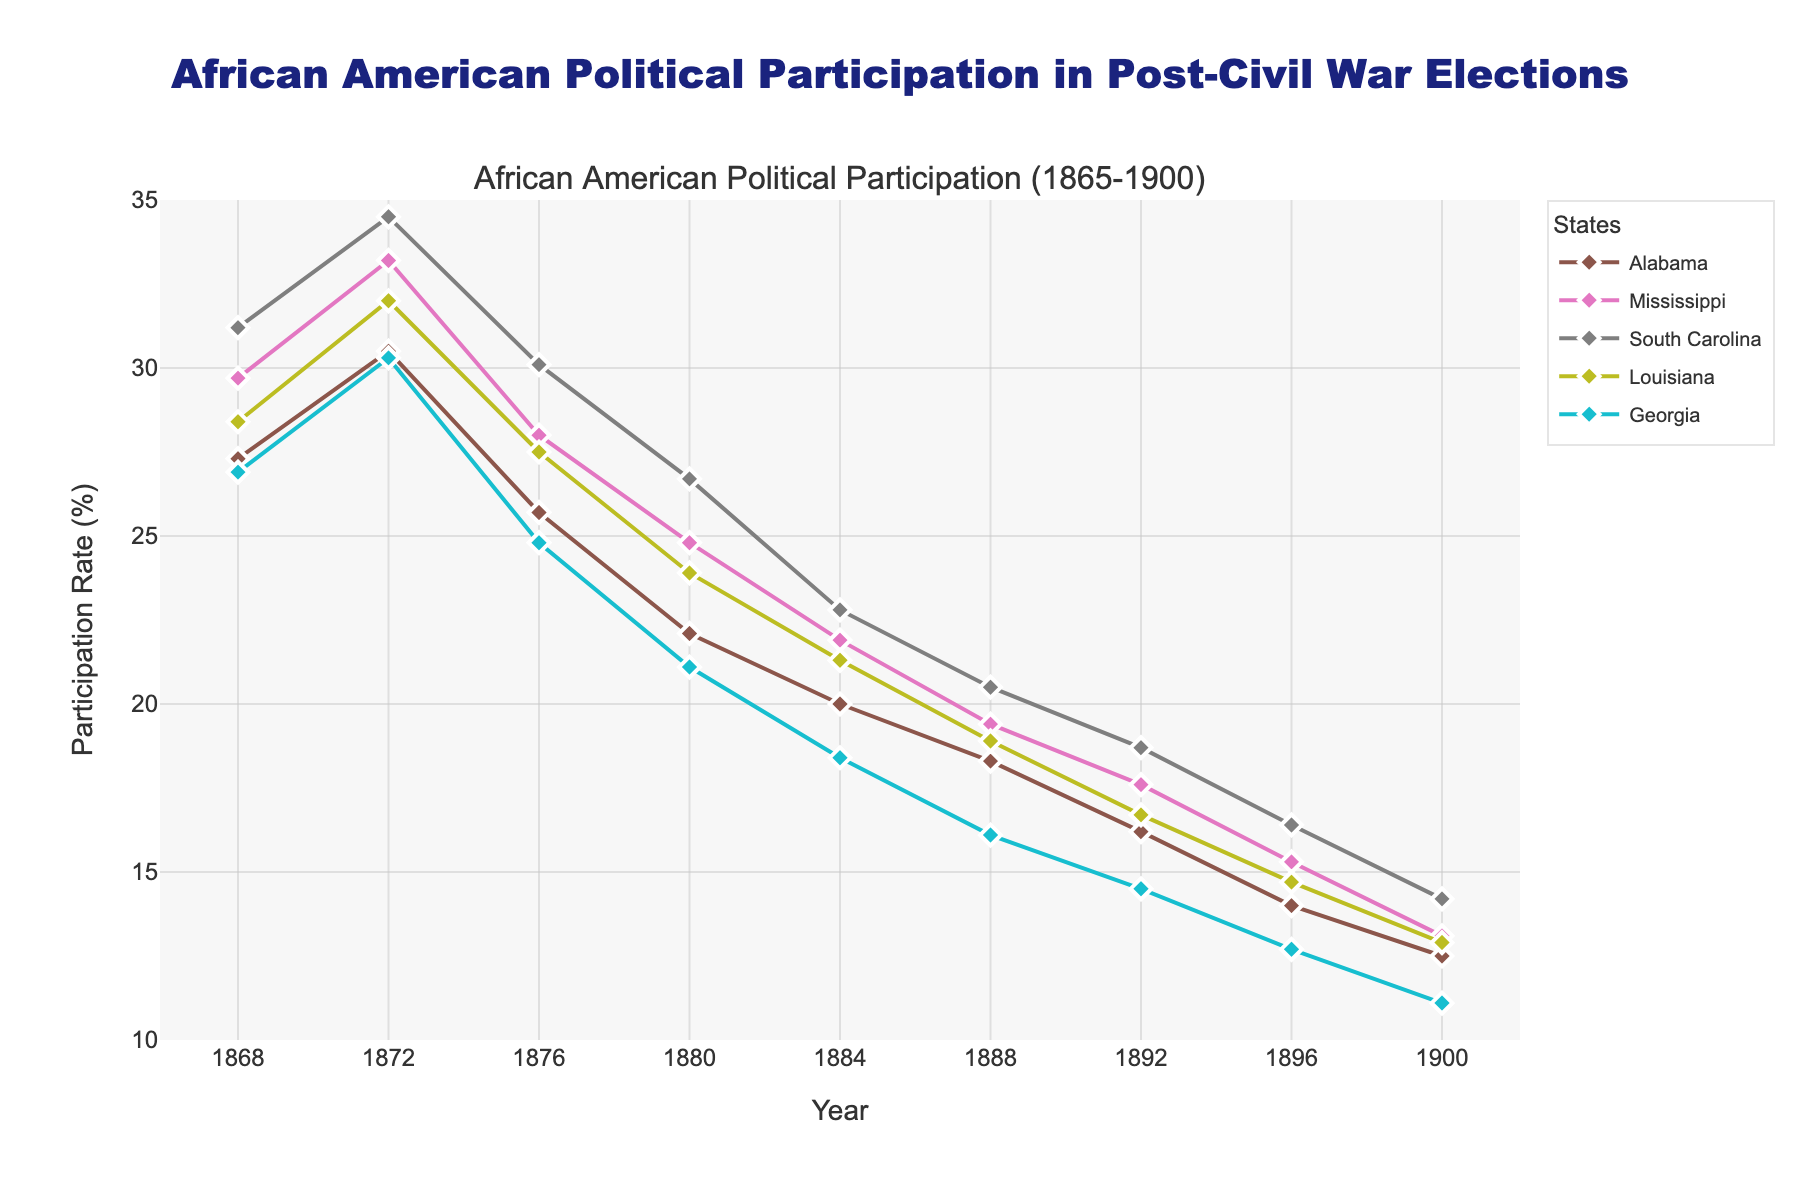What is the title of the figure? The title is usually found at the top of the figure. It provides an overall description of what the figure is about. In this case, it reads "African American Political Participation in Post-Civil War Elections".
Answer: African American Political Participation in Post-Civil War Elections What is the range of the x-axis? The x-axis represents the years from 1865 to 1900 in this figure. This can be deduced from the tick marks and labels on the x-axis, which span intervals of four years from 1865 to 1900.
Answer: 1865 to 1900 Which state shows the highest initial participation rate in 1868? To identify the highest initial participation rate in 1868, we look for the data points in the year 1868 and compare their y-values. South Carolina has a participation rate of 31.2%, which is the highest.
Answer: South Carolina How does the participation rate in Alabama change from 1868 to 1900? To find this out, we need to examine the data points for Alabama over the years. In 1868, the rate is 27.3%, and in 1900, it drops to 12.5%. This shows a clear decline over the years.
Answer: It decreases from 27.3% to 12.5% Which state shows the smallest decline in participation rate from 1868 to 1900? We need to calculate the difference between the 1868 and 1900 participation rates for all states. South Carolina declines from 31.2% to 14.2%, Alabama from 27.3% to 12.5%, Mississippi from 29.7% to 13.1%, Louisiana from 28.4% to 12.9%, and Georgia from 26.9% to 11.1%. The smallest decline is in South Carolina (17%).
Answer: South Carolina What is the average participation rate in 1872 across all states? We sum the participation rates of all states in 1872 and divide by the number of states. Alabama: 30.5%, Mississippi: 33.2%, South Carolina: 34.5%, Louisiana: 32.0%, Georgia: 30.3%. Average = (30.5 + 33.2 + 34.5 + 32.0 + 30.3) / 5 = 32.1%.
Answer: 32.1% Which state had the sharpest decline between 1872 and 1876? We calculate the participation rate difference for each state between 1872 and 1876. Alabama: 30.5% to 25.7% (4.8%), Mississippi: 33.2% to 28.0% (5.2%), South Carolina: 34.5% to 30.1% (4.4%), Louisiana: 32.0% to 27.5% (4.5%), Georgia: 30.3% to 24.8% (5.5%). Georgia had the sharpest decline of 5.5%.
Answer: Georgia How many years show a participation rate greater than 20% for South Carolina? We count the number of years in which the participation rate for South Carolina is above 20%. These years are 1868 (31.2%), 1872 (34.5%), 1876 (30.1%), 1880 (26.7%), and 1884 (22.8%). There are 5 such years.
Answer: 5 During which decade does Louisiana experience the steepest decline in participation rate? We examine the participation rates for Louisiana by decade: 1868-1878 shows a decline from 28.4% to 27.5% (0.9%), 1878-1888 shows a decline from 27.5% to 18.9% (8.6%), 1888-1898 shows a decline from 18.9% to 14.7% (4.2%), and 1898-1900 shows a decline from 14.7% to 12.9% (1.8%). The steepest decline is in the 1878-1888 decade.
Answer: 1878-1888 Which state shows the most consistent trend in the participation rate from 1868 to 1900? Consistency can be measured by assessing the smoothness of the line representing each state. Alabama and Mississippi have steady declines but some fluctuations. South Carolina's trend shows a consistent decline without sharp drops. By visual inspection, South Carolina appears to show the most consistent trend.
Answer: South Carolina 